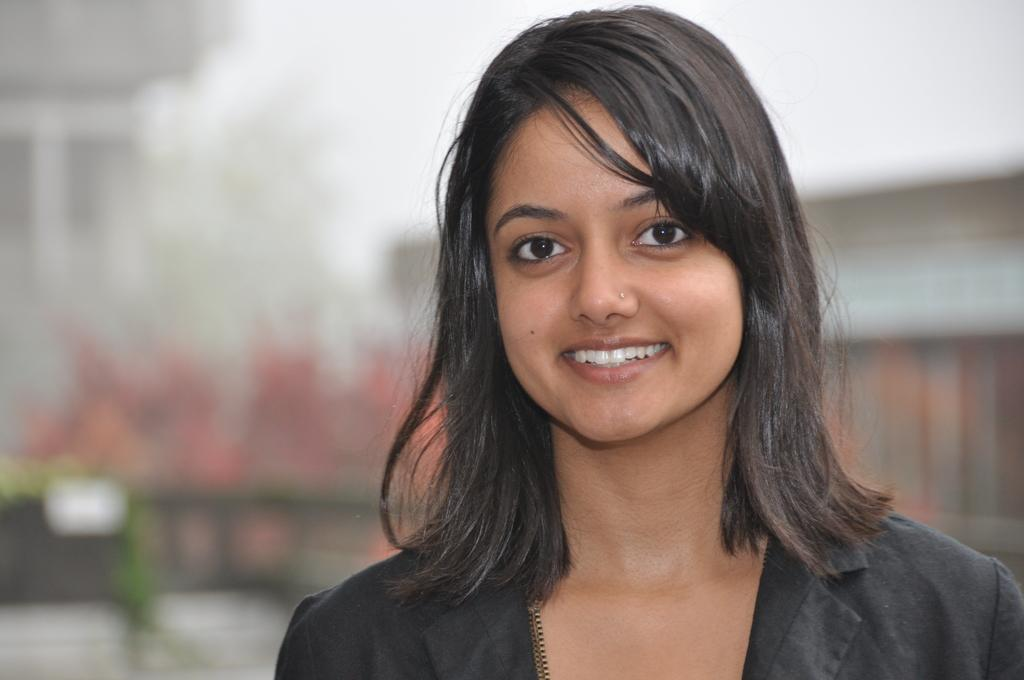Who is present in the image? There is a woman in the image. What is the woman's facial expression? The woman is smiling. Can you describe the background of the image? The background of the image is blurred. What type of brush is the woman using to participate in the discussion in the image? There is no brush or discussion present in the image; it features a woman smiling with a blurred background. 